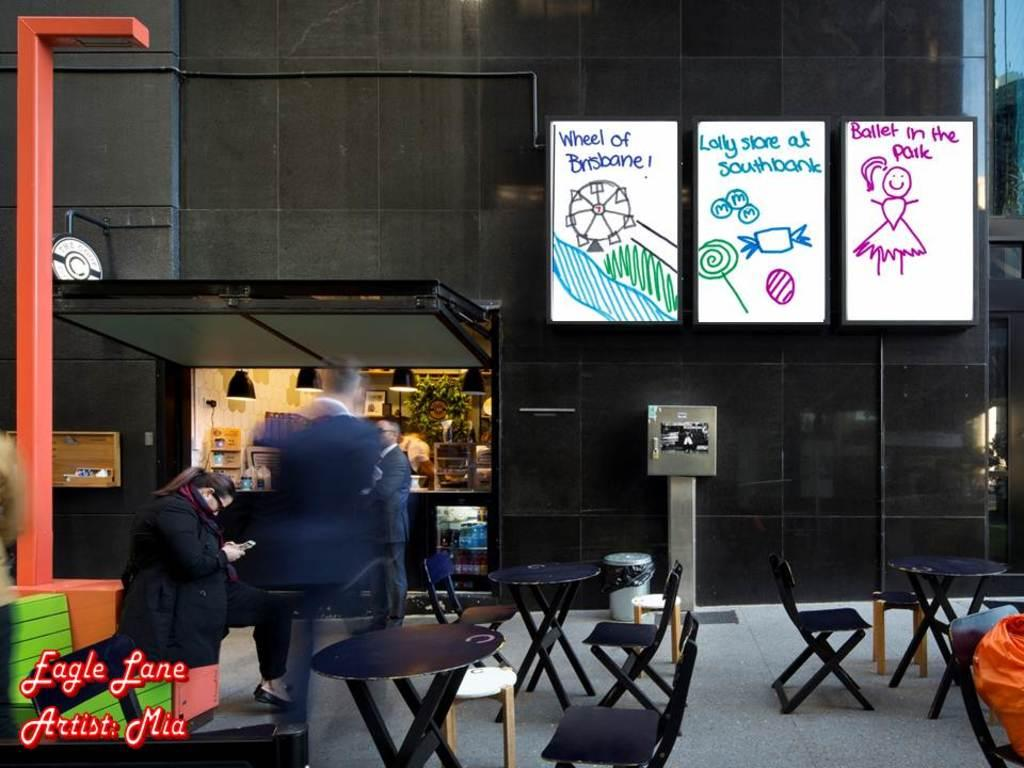What type of establishment is depicted in the image? There is a restaurant in the image. What is the primary purpose of the establishment? The primary purpose of the establishment is to serve food, as there is a food ordering place in the image. What type of furniture is present in the image? There are tables and chairs in the image. Are there any people present in the image? Yes, there are people standing in the image. What type of spiders can be seen crawling on the bed in the image? There is no bed or spiders present in the image; it features a restaurant with tables, chairs, and people. 